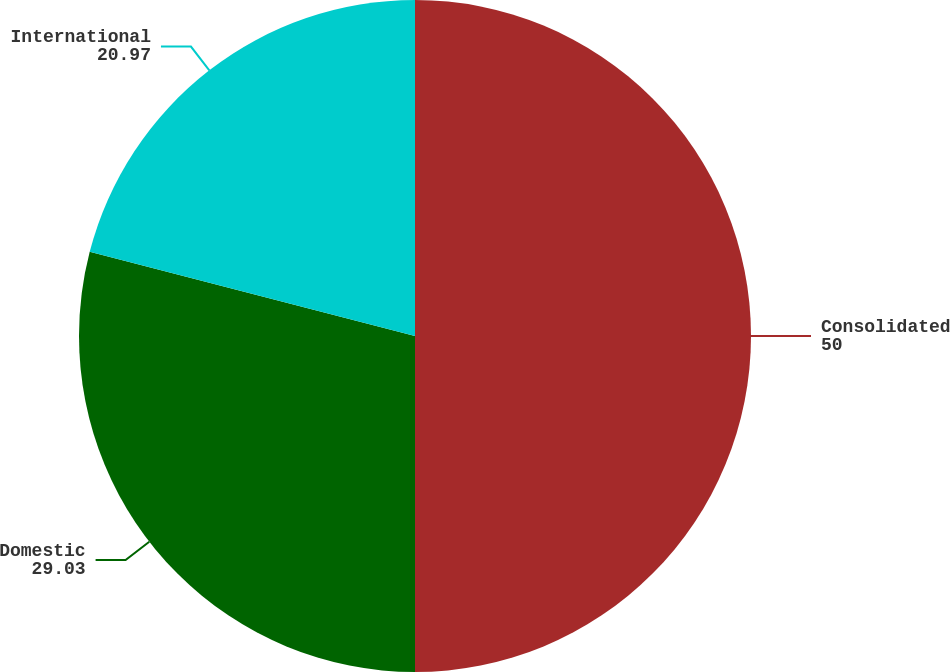Convert chart to OTSL. <chart><loc_0><loc_0><loc_500><loc_500><pie_chart><fcel>Consolidated<fcel>Domestic<fcel>International<nl><fcel>50.0%<fcel>29.03%<fcel>20.97%<nl></chart> 